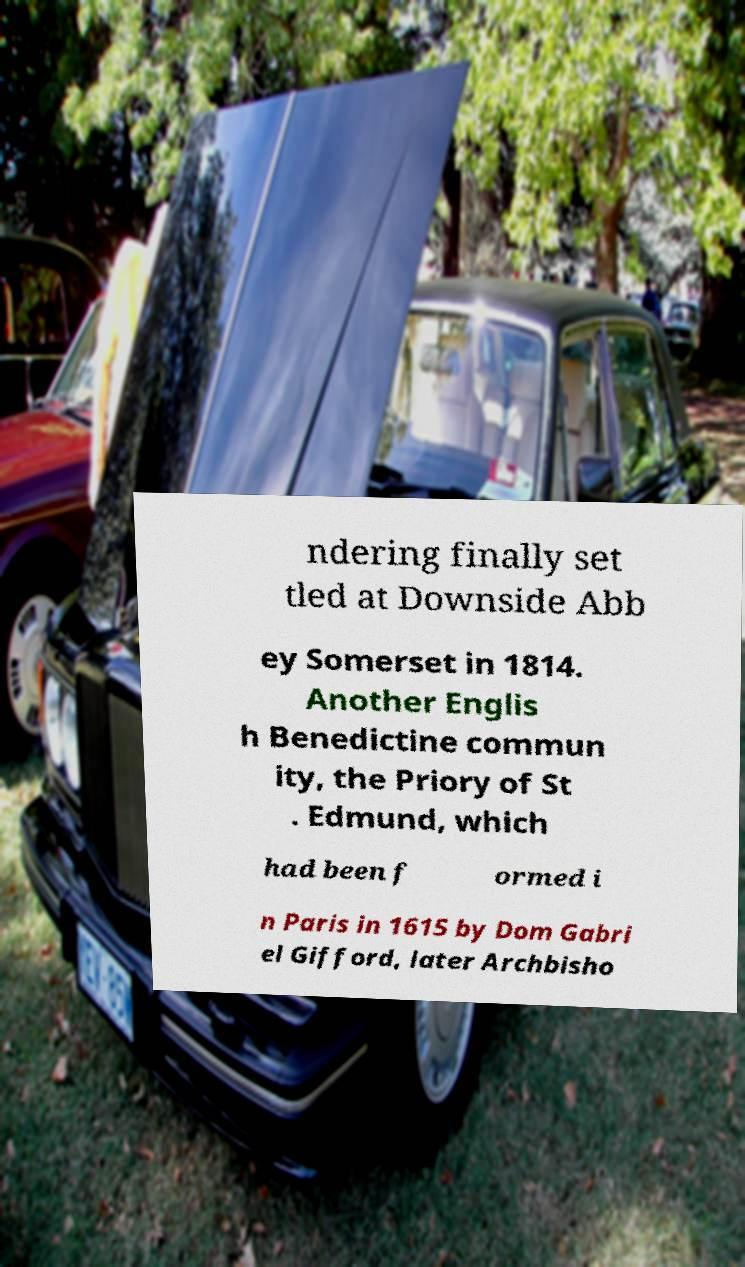Please identify and transcribe the text found in this image. ndering finally set tled at Downside Abb ey Somerset in 1814. Another Englis h Benedictine commun ity, the Priory of St . Edmund, which had been f ormed i n Paris in 1615 by Dom Gabri el Gifford, later Archbisho 